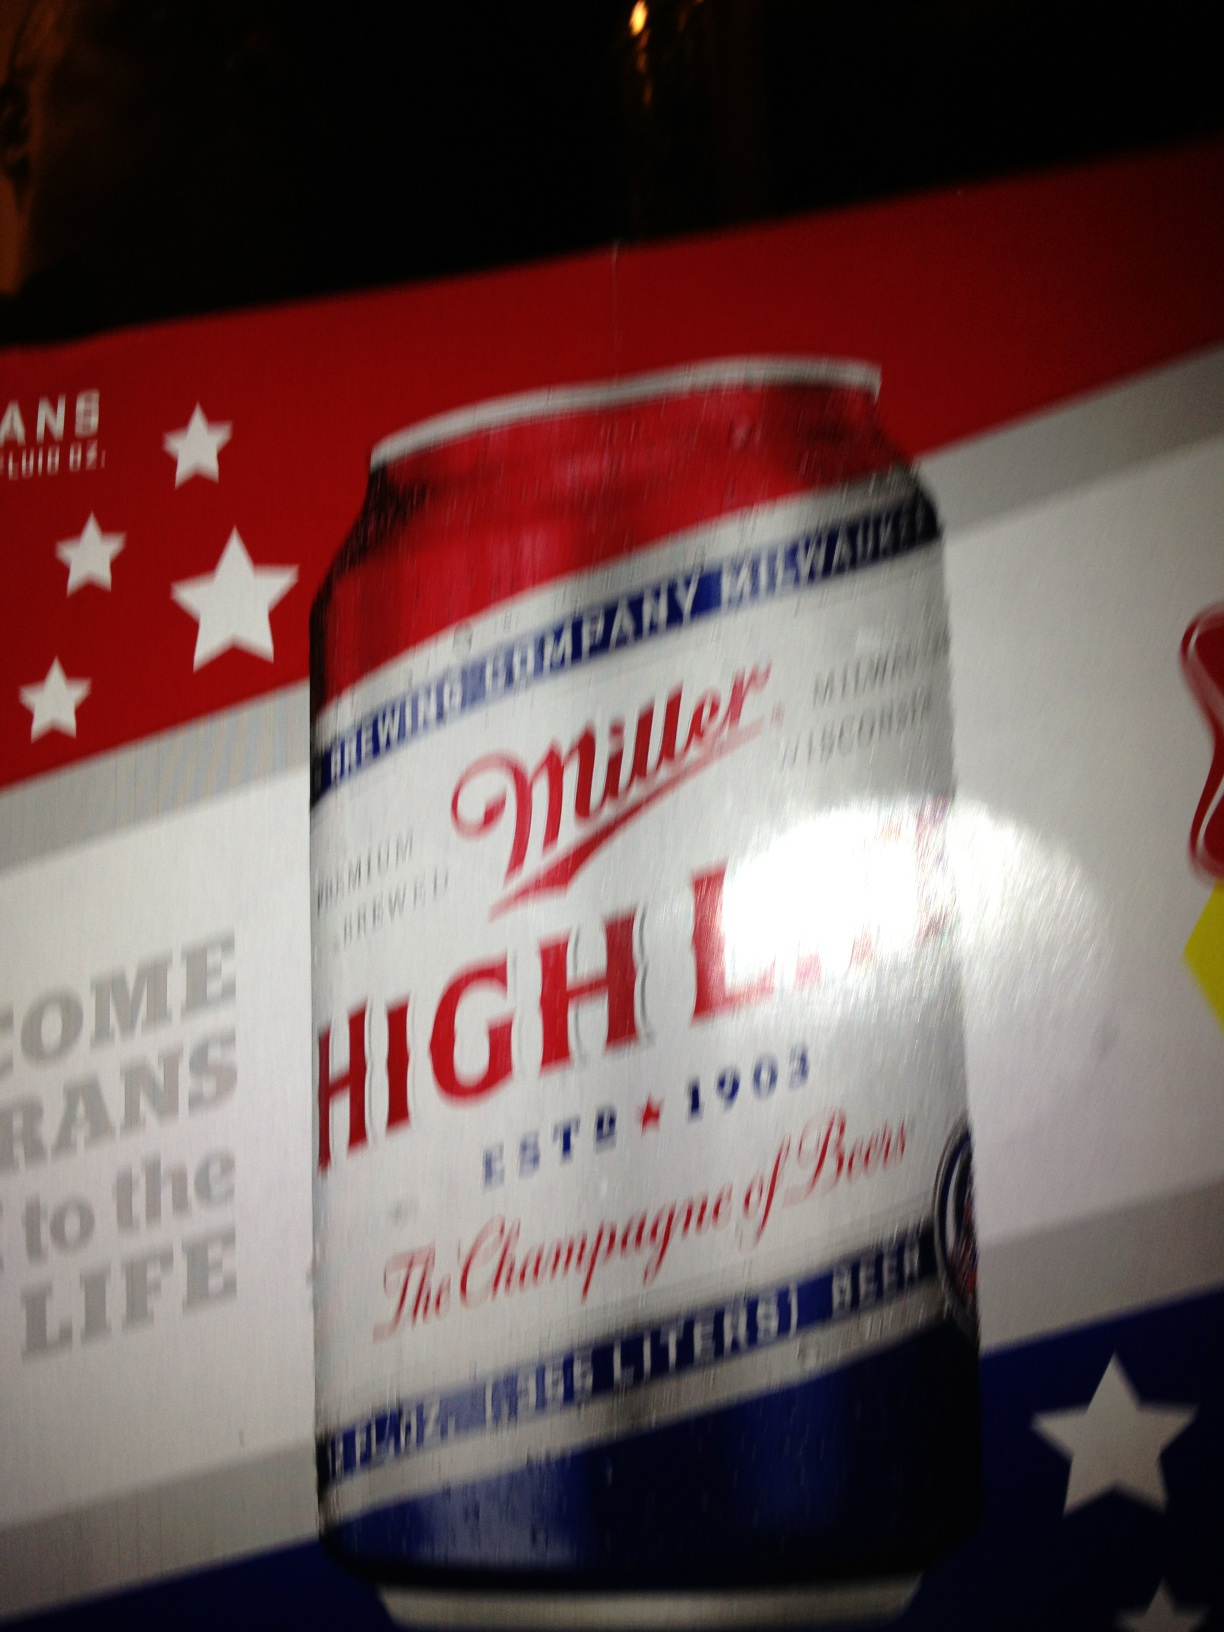What is this? This is a can of Miller High Life beer, often referred to as 'The Champagne of Beers.' It is an American-style lager established in 1903 and is known for its iconic, clear glass bottles and cans with red, white, and blue branding, reflective of its long-standing heritage. 